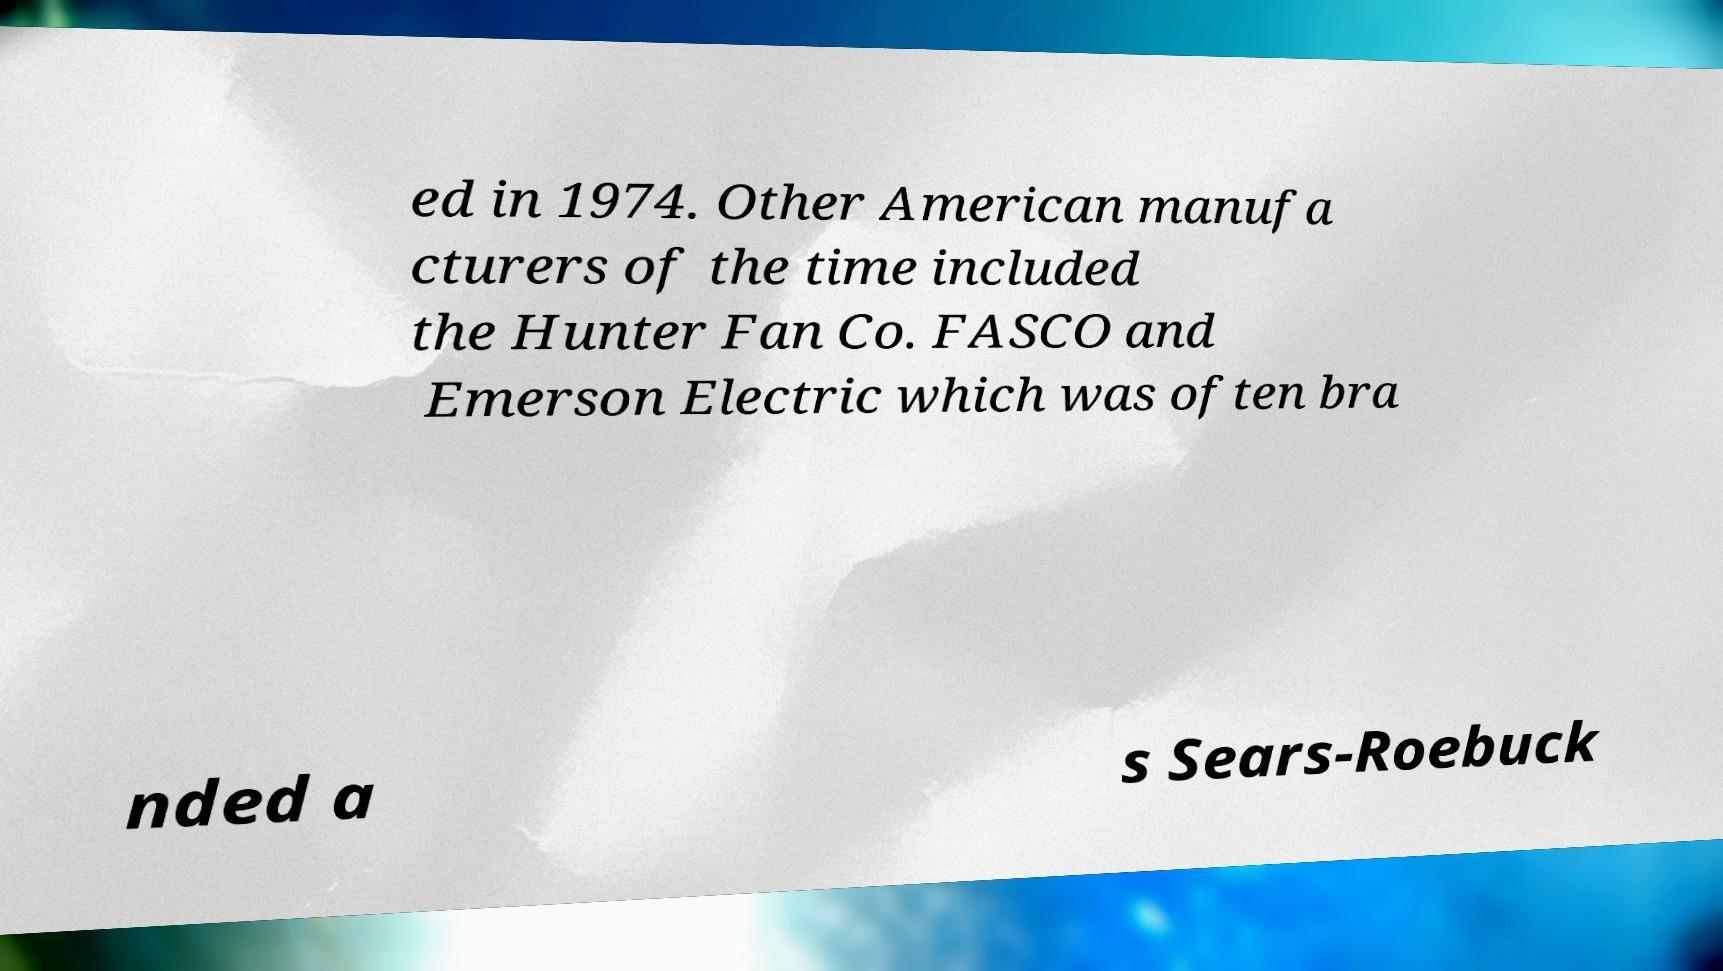Can you accurately transcribe the text from the provided image for me? ed in 1974. Other American manufa cturers of the time included the Hunter Fan Co. FASCO and Emerson Electric which was often bra nded a s Sears-Roebuck 